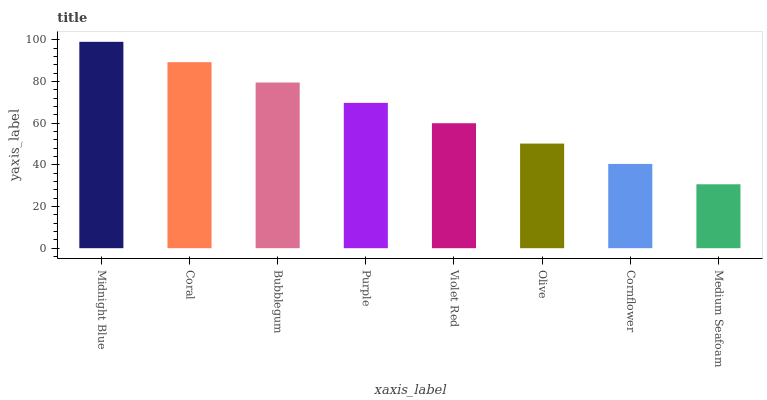Is Coral the minimum?
Answer yes or no. No. Is Coral the maximum?
Answer yes or no. No. Is Midnight Blue greater than Coral?
Answer yes or no. Yes. Is Coral less than Midnight Blue?
Answer yes or no. Yes. Is Coral greater than Midnight Blue?
Answer yes or no. No. Is Midnight Blue less than Coral?
Answer yes or no. No. Is Purple the high median?
Answer yes or no. Yes. Is Violet Red the low median?
Answer yes or no. Yes. Is Coral the high median?
Answer yes or no. No. Is Purple the low median?
Answer yes or no. No. 